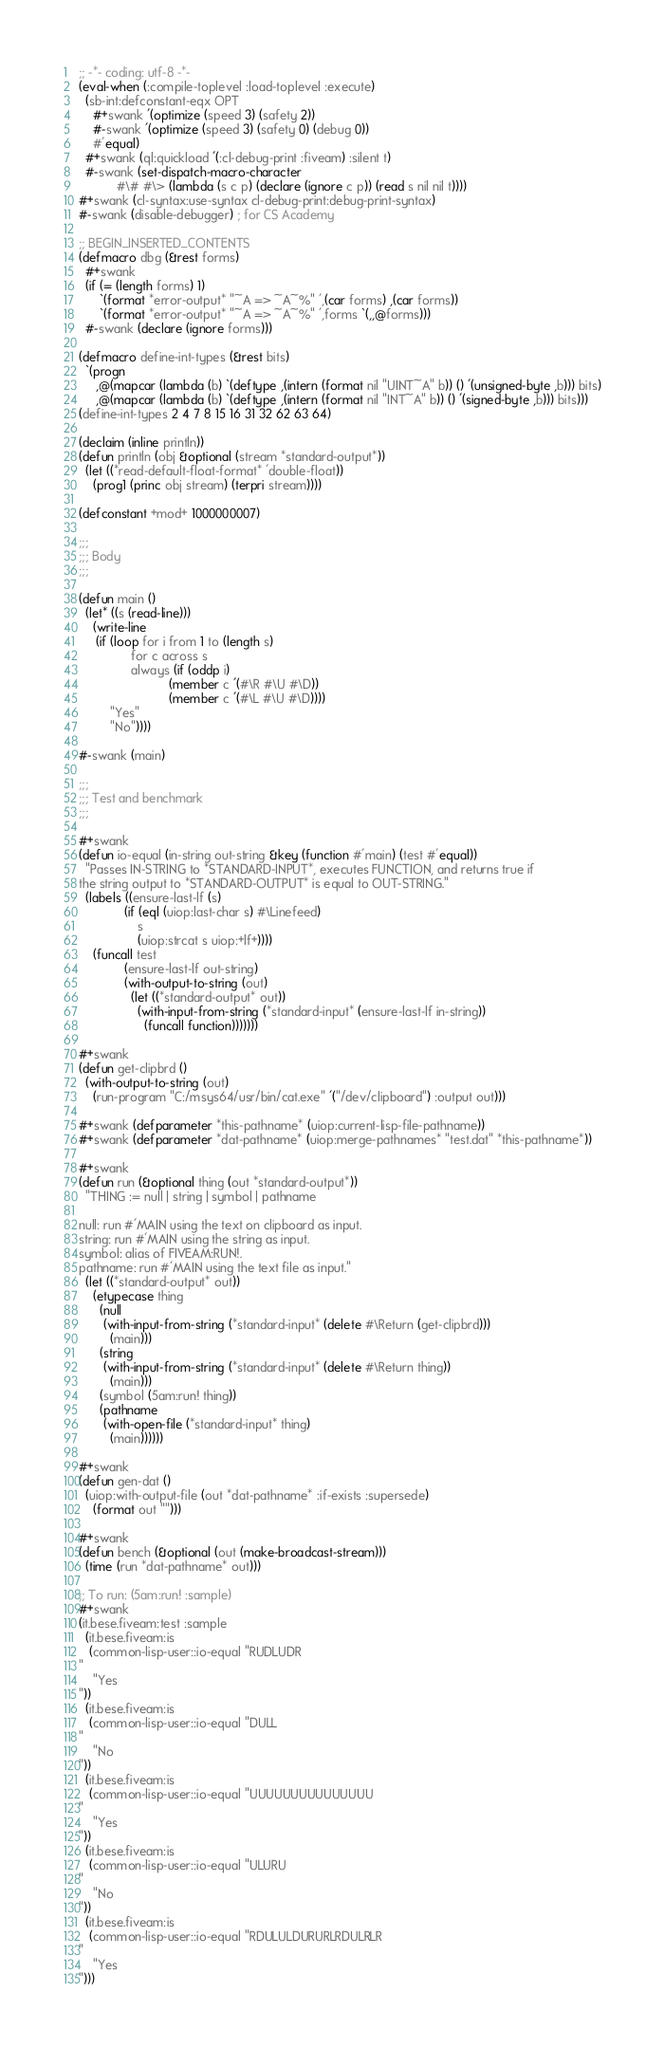<code> <loc_0><loc_0><loc_500><loc_500><_Lisp_>;; -*- coding: utf-8 -*-
(eval-when (:compile-toplevel :load-toplevel :execute)
  (sb-int:defconstant-eqx OPT
    #+swank '(optimize (speed 3) (safety 2))
    #-swank '(optimize (speed 3) (safety 0) (debug 0))
    #'equal)
  #+swank (ql:quickload '(:cl-debug-print :fiveam) :silent t)
  #-swank (set-dispatch-macro-character
           #\# #\> (lambda (s c p) (declare (ignore c p)) (read s nil nil t))))
#+swank (cl-syntax:use-syntax cl-debug-print:debug-print-syntax)
#-swank (disable-debugger) ; for CS Academy

;; BEGIN_INSERTED_CONTENTS
(defmacro dbg (&rest forms)
  #+swank
  (if (= (length forms) 1)
      `(format *error-output* "~A => ~A~%" ',(car forms) ,(car forms))
      `(format *error-output* "~A => ~A~%" ',forms `(,,@forms)))
  #-swank (declare (ignore forms)))

(defmacro define-int-types (&rest bits)
  `(progn
     ,@(mapcar (lambda (b) `(deftype ,(intern (format nil "UINT~A" b)) () '(unsigned-byte ,b))) bits)
     ,@(mapcar (lambda (b) `(deftype ,(intern (format nil "INT~A" b)) () '(signed-byte ,b))) bits)))
(define-int-types 2 4 7 8 15 16 31 32 62 63 64)

(declaim (inline println))
(defun println (obj &optional (stream *standard-output*))
  (let ((*read-default-float-format* 'double-float))
    (prog1 (princ obj stream) (terpri stream))))

(defconstant +mod+ 1000000007)

;;;
;;; Body
;;;

(defun main ()
  (let* ((s (read-line)))
    (write-line
     (if (loop for i from 1 to (length s)
               for c across s
               always (if (oddp i)
                          (member c '(#\R #\U #\D))
                          (member c '(#\L #\U #\D))))
         "Yes"
         "No"))))

#-swank (main)

;;;
;;; Test and benchmark
;;;

#+swank
(defun io-equal (in-string out-string &key (function #'main) (test #'equal))
  "Passes IN-STRING to *STANDARD-INPUT*, executes FUNCTION, and returns true if
the string output to *STANDARD-OUTPUT* is equal to OUT-STRING."
  (labels ((ensure-last-lf (s)
             (if (eql (uiop:last-char s) #\Linefeed)
                 s
                 (uiop:strcat s uiop:+lf+))))
    (funcall test
             (ensure-last-lf out-string)
             (with-output-to-string (out)
               (let ((*standard-output* out))
                 (with-input-from-string (*standard-input* (ensure-last-lf in-string))
                   (funcall function)))))))

#+swank
(defun get-clipbrd ()
  (with-output-to-string (out)
    (run-program "C:/msys64/usr/bin/cat.exe" '("/dev/clipboard") :output out)))

#+swank (defparameter *this-pathname* (uiop:current-lisp-file-pathname))
#+swank (defparameter *dat-pathname* (uiop:merge-pathnames* "test.dat" *this-pathname*))

#+swank
(defun run (&optional thing (out *standard-output*))
  "THING := null | string | symbol | pathname

null: run #'MAIN using the text on clipboard as input.
string: run #'MAIN using the string as input.
symbol: alias of FIVEAM:RUN!.
pathname: run #'MAIN using the text file as input."
  (let ((*standard-output* out))
    (etypecase thing
      (null
       (with-input-from-string (*standard-input* (delete #\Return (get-clipbrd)))
         (main)))
      (string
       (with-input-from-string (*standard-input* (delete #\Return thing))
         (main)))
      (symbol (5am:run! thing))
      (pathname
       (with-open-file (*standard-input* thing)
         (main))))))

#+swank
(defun gen-dat ()
  (uiop:with-output-file (out *dat-pathname* :if-exists :supersede)
    (format out "")))

#+swank
(defun bench (&optional (out (make-broadcast-stream)))
  (time (run *dat-pathname* out)))

;; To run: (5am:run! :sample)
#+swank
(it.bese.fiveam:test :sample
  (it.bese.fiveam:is
   (common-lisp-user::io-equal "RUDLUDR
"
    "Yes
"))
  (it.bese.fiveam:is
   (common-lisp-user::io-equal "DULL
"
    "No
"))
  (it.bese.fiveam:is
   (common-lisp-user::io-equal "UUUUUUUUUUUUUUU
"
    "Yes
"))
  (it.bese.fiveam:is
   (common-lisp-user::io-equal "ULURU
"
    "No
"))
  (it.bese.fiveam:is
   (common-lisp-user::io-equal "RDULULDURURLRDULRLR
"
    "Yes
")))
</code> 